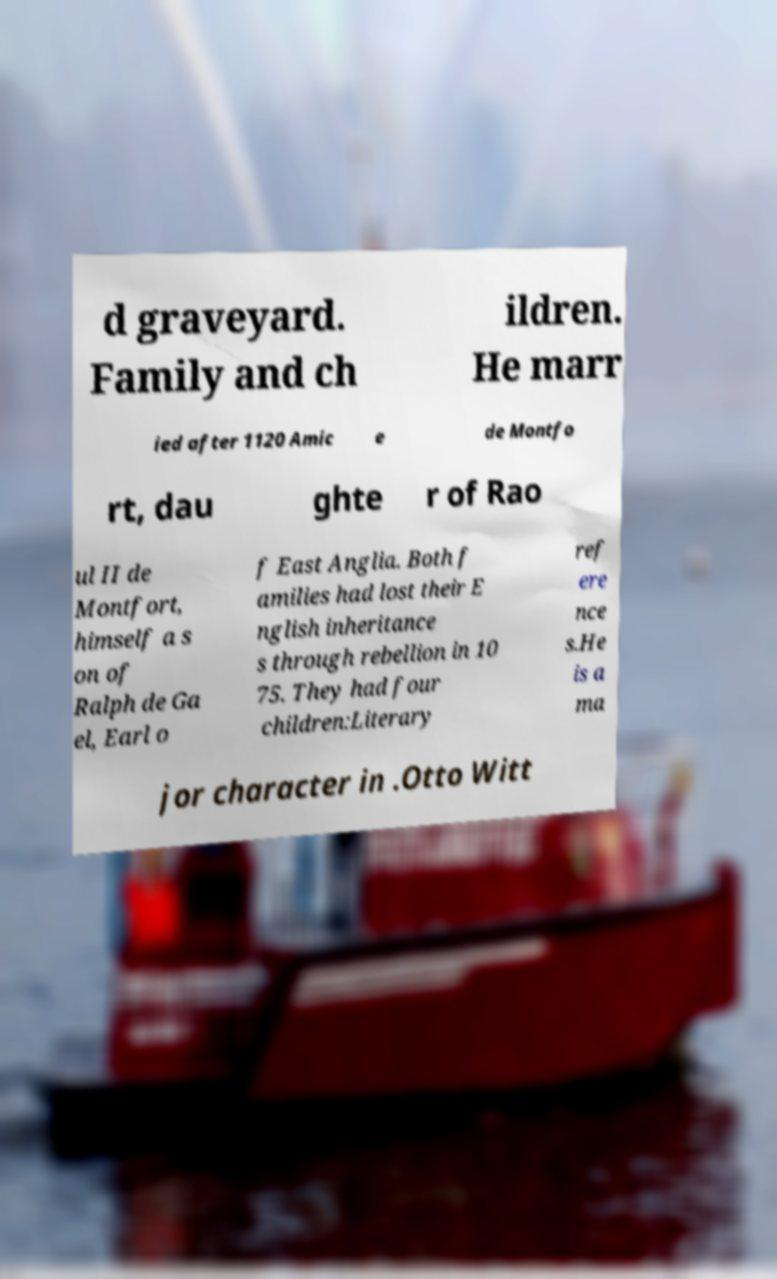There's text embedded in this image that I need extracted. Can you transcribe it verbatim? d graveyard. Family and ch ildren. He marr ied after 1120 Amic e de Montfo rt, dau ghte r of Rao ul II de Montfort, himself a s on of Ralph de Ga el, Earl o f East Anglia. Both f amilies had lost their E nglish inheritance s through rebellion in 10 75. They had four children:Literary ref ere nce s.He is a ma jor character in .Otto Witt 